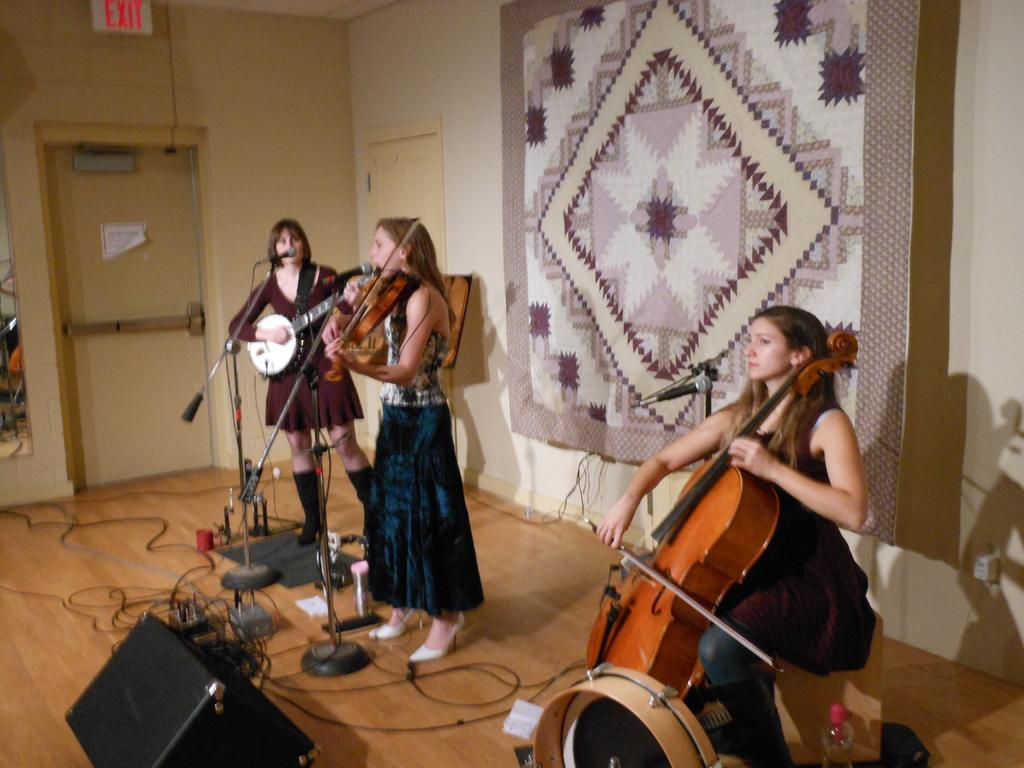How many women are in the image? There are three women in the image. What are the women doing in the image? The women are holding musical instruments. What positions are the women in? Two of the women are standing, and one is sitting. What objects are in front of the women? There are mics in front of the women. Can you see any rabbits swimming in the image? There are no rabbits or swimming activity present in the image. 